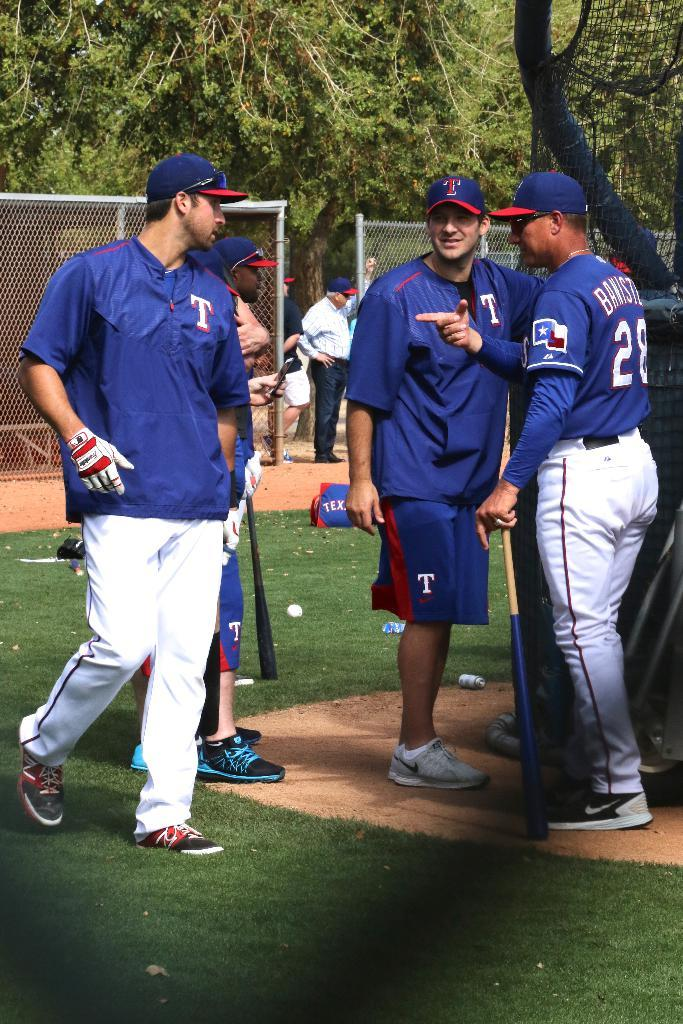Provide a one-sentence caption for the provided image. 3 baseball players wearing a blue uniform with a T on it. 